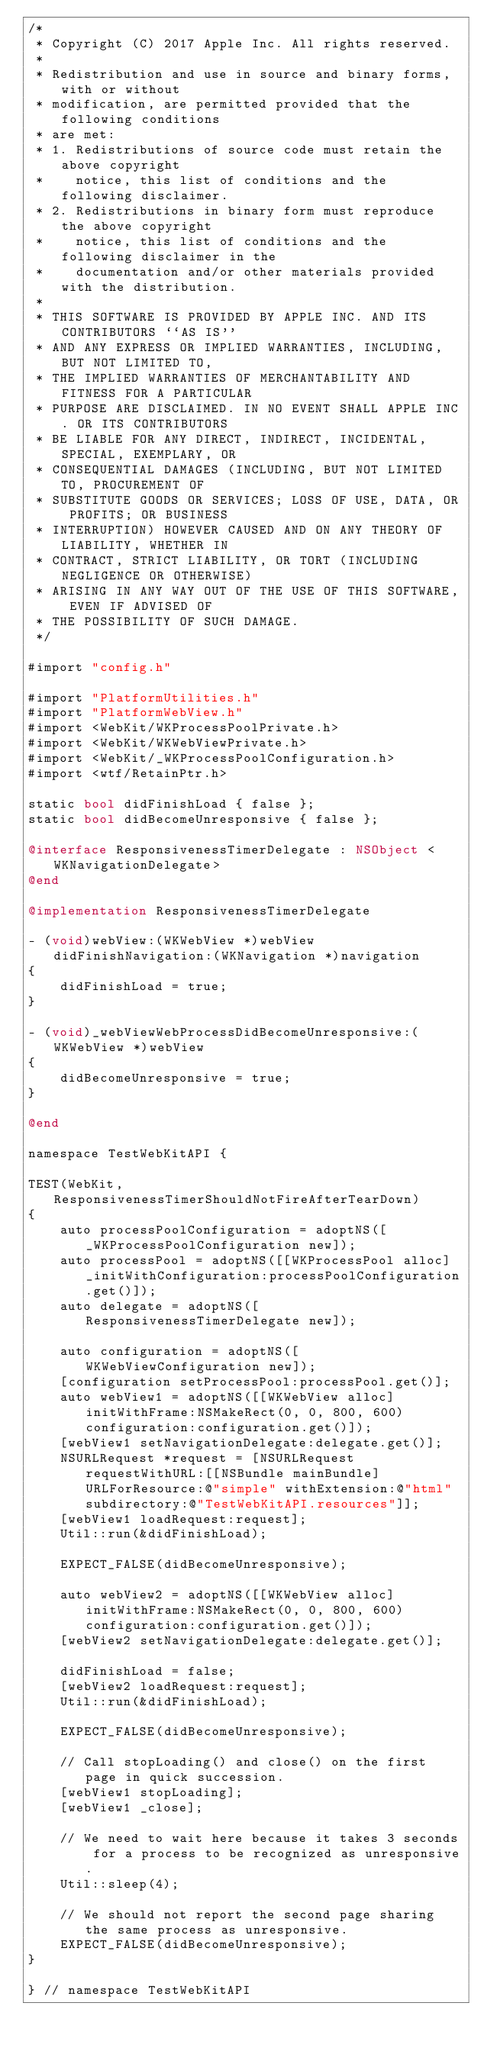Convert code to text. <code><loc_0><loc_0><loc_500><loc_500><_ObjectiveC_>/*
 * Copyright (C) 2017 Apple Inc. All rights reserved.
 *
 * Redistribution and use in source and binary forms, with or without
 * modification, are permitted provided that the following conditions
 * are met:
 * 1. Redistributions of source code must retain the above copyright
 *    notice, this list of conditions and the following disclaimer.
 * 2. Redistributions in binary form must reproduce the above copyright
 *    notice, this list of conditions and the following disclaimer in the
 *    documentation and/or other materials provided with the distribution.
 *
 * THIS SOFTWARE IS PROVIDED BY APPLE INC. AND ITS CONTRIBUTORS ``AS IS''
 * AND ANY EXPRESS OR IMPLIED WARRANTIES, INCLUDING, BUT NOT LIMITED TO,
 * THE IMPLIED WARRANTIES OF MERCHANTABILITY AND FITNESS FOR A PARTICULAR
 * PURPOSE ARE DISCLAIMED. IN NO EVENT SHALL APPLE INC. OR ITS CONTRIBUTORS
 * BE LIABLE FOR ANY DIRECT, INDIRECT, INCIDENTAL, SPECIAL, EXEMPLARY, OR
 * CONSEQUENTIAL DAMAGES (INCLUDING, BUT NOT LIMITED TO, PROCUREMENT OF
 * SUBSTITUTE GOODS OR SERVICES; LOSS OF USE, DATA, OR PROFITS; OR BUSINESS
 * INTERRUPTION) HOWEVER CAUSED AND ON ANY THEORY OF LIABILITY, WHETHER IN
 * CONTRACT, STRICT LIABILITY, OR TORT (INCLUDING NEGLIGENCE OR OTHERWISE)
 * ARISING IN ANY WAY OUT OF THE USE OF THIS SOFTWARE, EVEN IF ADVISED OF
 * THE POSSIBILITY OF SUCH DAMAGE.
 */

#import "config.h"

#import "PlatformUtilities.h"
#import "PlatformWebView.h"
#import <WebKit/WKProcessPoolPrivate.h>
#import <WebKit/WKWebViewPrivate.h>
#import <WebKit/_WKProcessPoolConfiguration.h>
#import <wtf/RetainPtr.h>

static bool didFinishLoad { false };
static bool didBecomeUnresponsive { false };

@interface ResponsivenessTimerDelegate : NSObject <WKNavigationDelegate>
@end
    
@implementation ResponsivenessTimerDelegate

- (void)webView:(WKWebView *)webView didFinishNavigation:(WKNavigation *)navigation
{
    didFinishLoad = true;
}

- (void)_webViewWebProcessDidBecomeUnresponsive:(WKWebView *)webView
{
    didBecomeUnresponsive = true;
}

@end

namespace TestWebKitAPI {

TEST(WebKit, ResponsivenessTimerShouldNotFireAfterTearDown)
{
    auto processPoolConfiguration = adoptNS([_WKProcessPoolConfiguration new]);
    auto processPool = adoptNS([[WKProcessPool alloc] _initWithConfiguration:processPoolConfiguration.get()]);
    auto delegate = adoptNS([ResponsivenessTimerDelegate new]);

    auto configuration = adoptNS([WKWebViewConfiguration new]);
    [configuration setProcessPool:processPool.get()];
    auto webView1 = adoptNS([[WKWebView alloc] initWithFrame:NSMakeRect(0, 0, 800, 600) configuration:configuration.get()]);
    [webView1 setNavigationDelegate:delegate.get()];
    NSURLRequest *request = [NSURLRequest requestWithURL:[[NSBundle mainBundle] URLForResource:@"simple" withExtension:@"html" subdirectory:@"TestWebKitAPI.resources"]];
    [webView1 loadRequest:request];
    Util::run(&didFinishLoad);

    EXPECT_FALSE(didBecomeUnresponsive);

    auto webView2 = adoptNS([[WKWebView alloc] initWithFrame:NSMakeRect(0, 0, 800, 600) configuration:configuration.get()]);
    [webView2 setNavigationDelegate:delegate.get()];

    didFinishLoad = false;
    [webView2 loadRequest:request];
    Util::run(&didFinishLoad);

    EXPECT_FALSE(didBecomeUnresponsive);

    // Call stopLoading() and close() on the first page in quick succession.
    [webView1 stopLoading];
    [webView1 _close];

    // We need to wait here because it takes 3 seconds for a process to be recognized as unresponsive.
    Util::sleep(4);

    // We should not report the second page sharing the same process as unresponsive.
    EXPECT_FALSE(didBecomeUnresponsive);
}

} // namespace TestWebKitAPI
</code> 